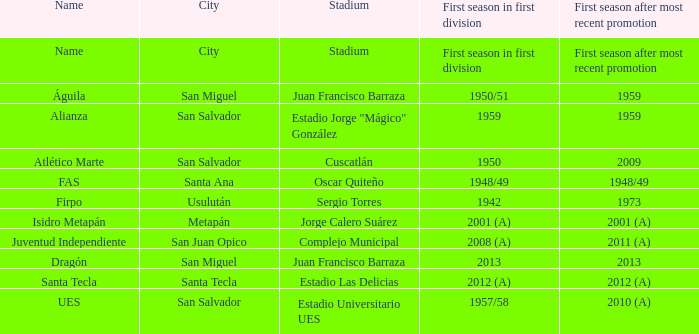In which year did alianza have their debut season in the first division after earning a promotion subsequent to 1959? 1959.0. 